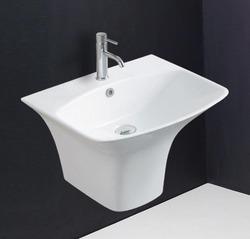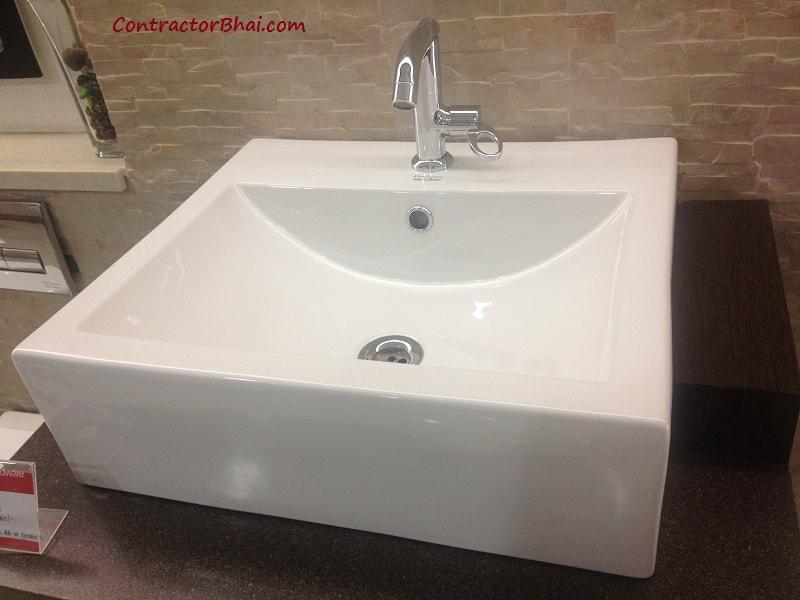The first image is the image on the left, the second image is the image on the right. Given the left and right images, does the statement "At least one sink is sitting on a counter." hold true? Answer yes or no. Yes. 